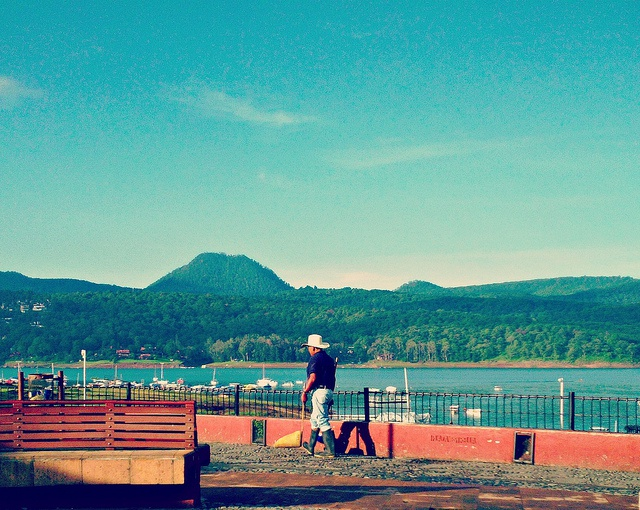Describe the objects in this image and their specific colors. I can see bench in teal, salmon, navy, and brown tones, people in teal, navy, and beige tones, boat in teal, darkgray, gray, and olive tones, boat in teal, darkgray, tan, gray, and black tones, and boat in teal, beige, darkgray, and tan tones in this image. 